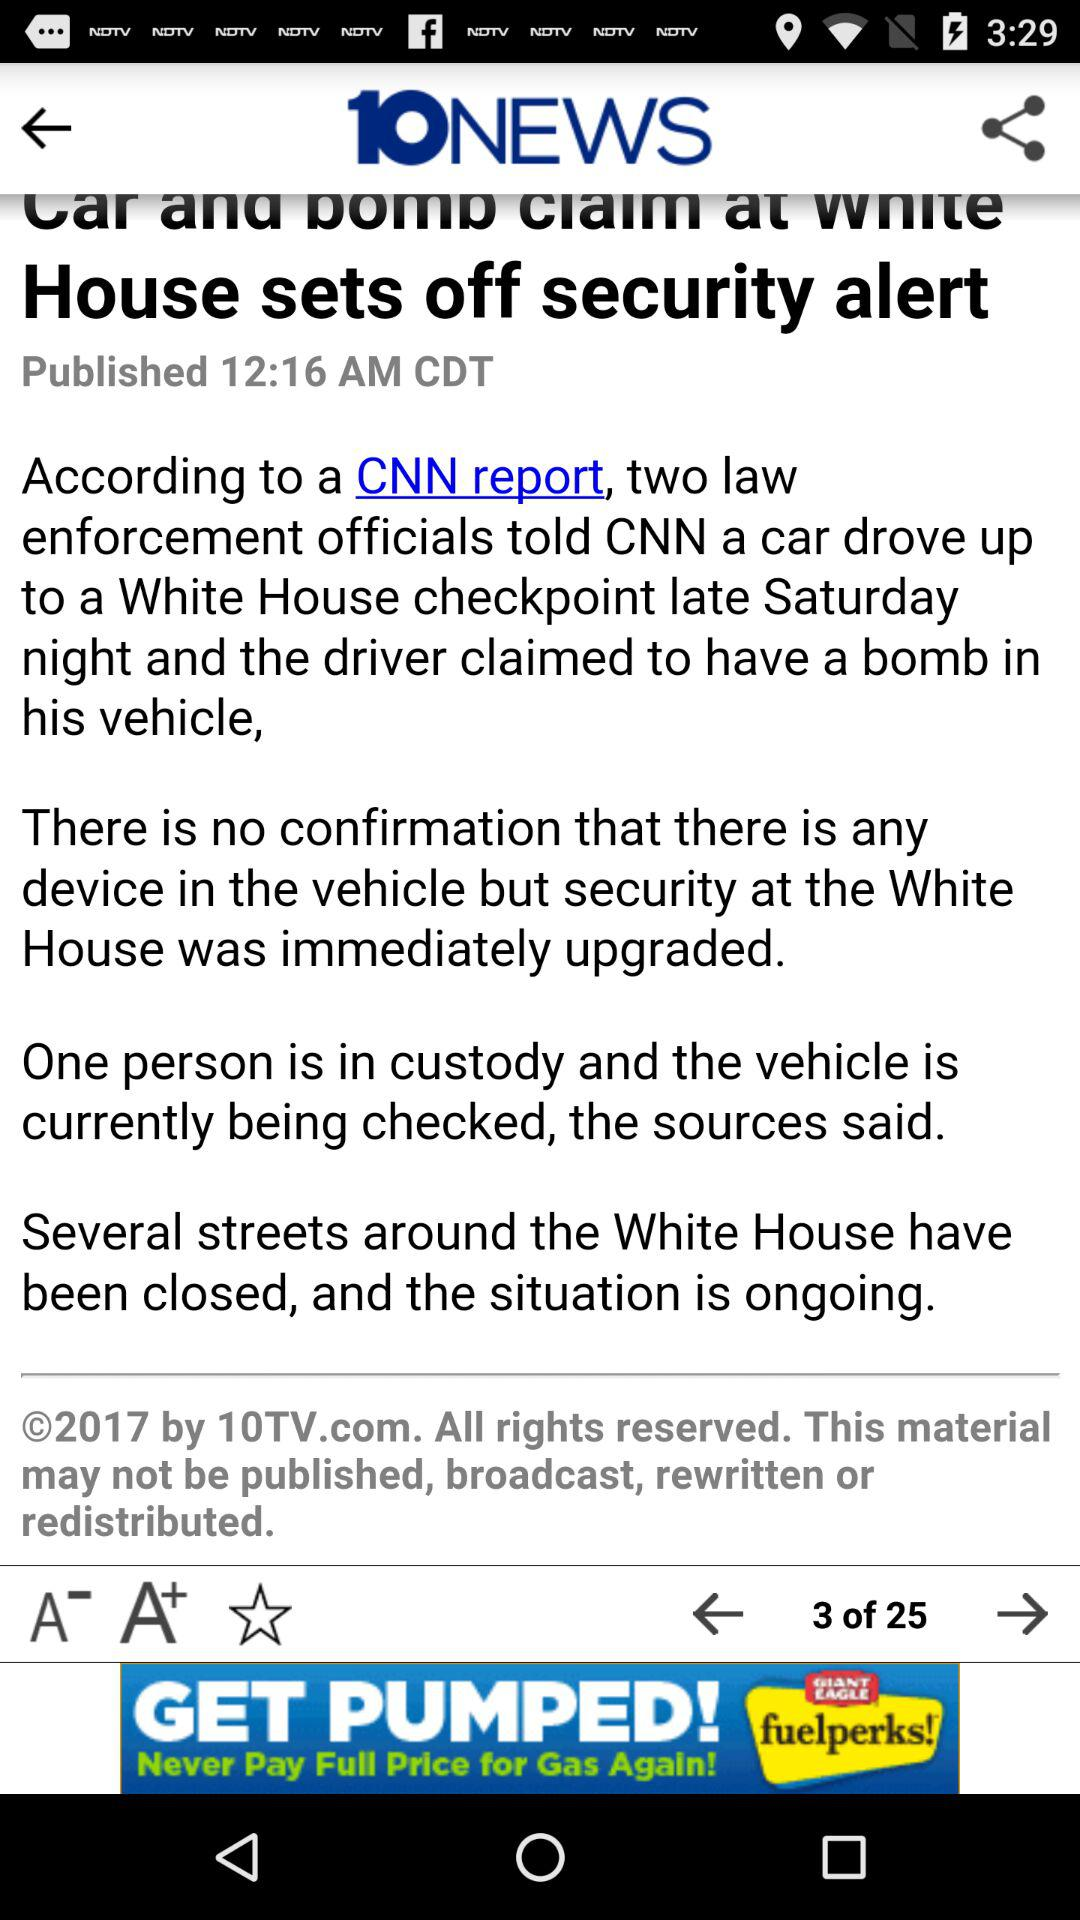What page of content am I on? I am on page 3. 